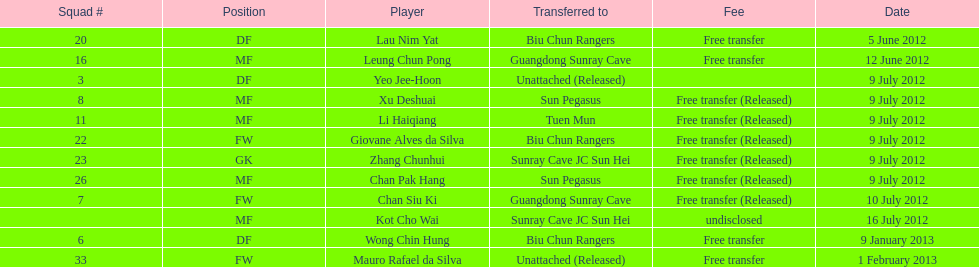How many players were moved to sun pegasus in total? 2. 